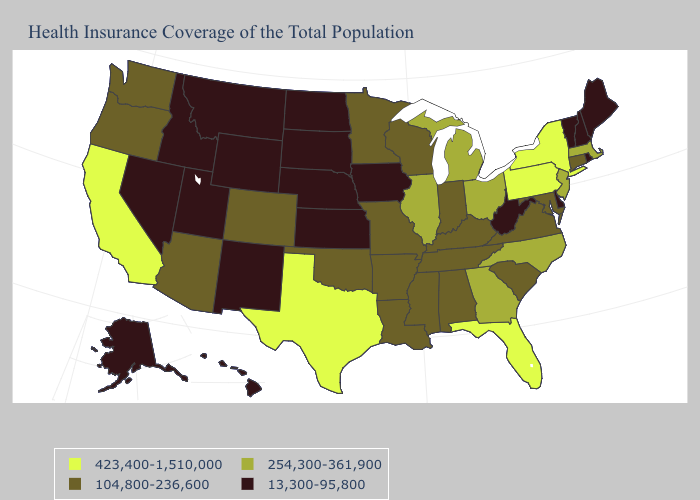What is the value of Alaska?
Give a very brief answer. 13,300-95,800. Name the states that have a value in the range 104,800-236,600?
Short answer required. Alabama, Arizona, Arkansas, Colorado, Connecticut, Indiana, Kentucky, Louisiana, Maryland, Minnesota, Mississippi, Missouri, Oklahoma, Oregon, South Carolina, Tennessee, Virginia, Washington, Wisconsin. What is the value of Georgia?
Quick response, please. 254,300-361,900. Does the first symbol in the legend represent the smallest category?
Give a very brief answer. No. Name the states that have a value in the range 423,400-1,510,000?
Give a very brief answer. California, Florida, New York, Pennsylvania, Texas. What is the lowest value in the West?
Answer briefly. 13,300-95,800. Does West Virginia have the lowest value in the South?
Keep it brief. Yes. What is the value of Minnesota?
Answer briefly. 104,800-236,600. Name the states that have a value in the range 254,300-361,900?
Answer briefly. Georgia, Illinois, Massachusetts, Michigan, New Jersey, North Carolina, Ohio. Does Vermont have the highest value in the USA?
Give a very brief answer. No. What is the highest value in the USA?
Be succinct. 423,400-1,510,000. How many symbols are there in the legend?
Answer briefly. 4. What is the highest value in states that border Mississippi?
Concise answer only. 104,800-236,600. What is the value of Kansas?
Give a very brief answer. 13,300-95,800. 